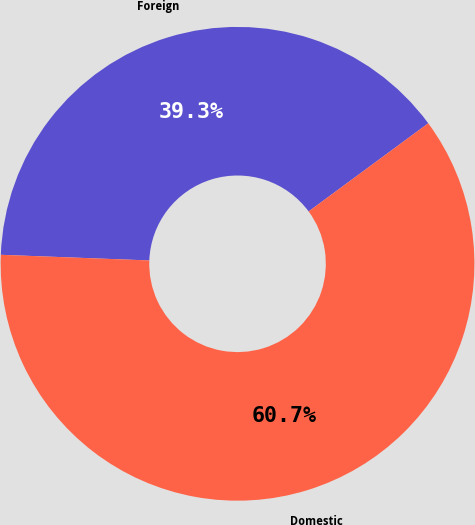Convert chart. <chart><loc_0><loc_0><loc_500><loc_500><pie_chart><fcel>Foreign<fcel>Domestic<nl><fcel>39.29%<fcel>60.71%<nl></chart> 